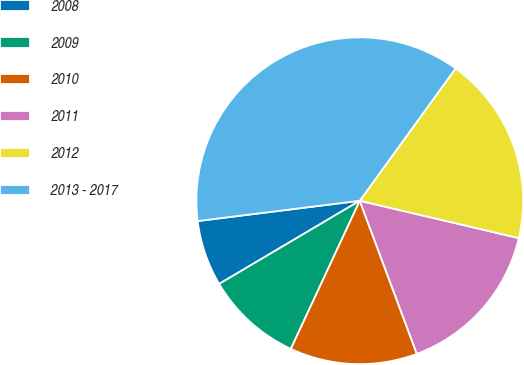Convert chart. <chart><loc_0><loc_0><loc_500><loc_500><pie_chart><fcel>2008<fcel>2009<fcel>2010<fcel>2011<fcel>2012<fcel>2013 - 2017<nl><fcel>6.52%<fcel>9.57%<fcel>12.61%<fcel>15.65%<fcel>18.7%<fcel>36.96%<nl></chart> 